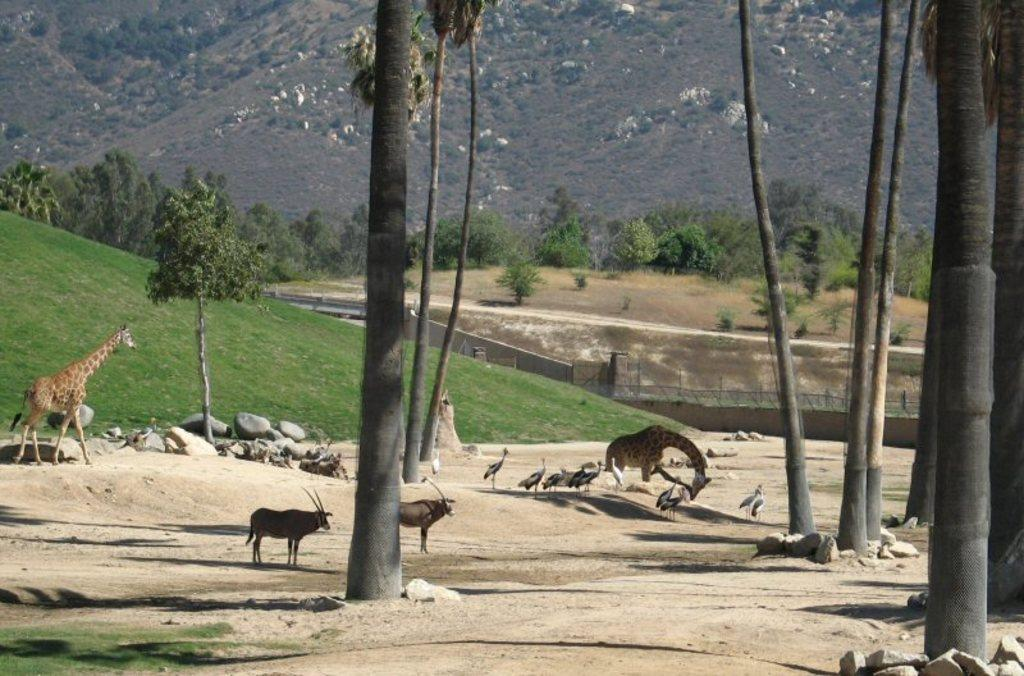How many giraffes are present in the image? There are two giraffes in the image. What other animals can be seen in the image besides giraffes? There are other animals in the image, including birds. What can be seen in the background of the image? There are trees and mountains in the background of the image. How much does the dime cost in the image? There is no dime present in the image, so it is not possible to determine its cost. 